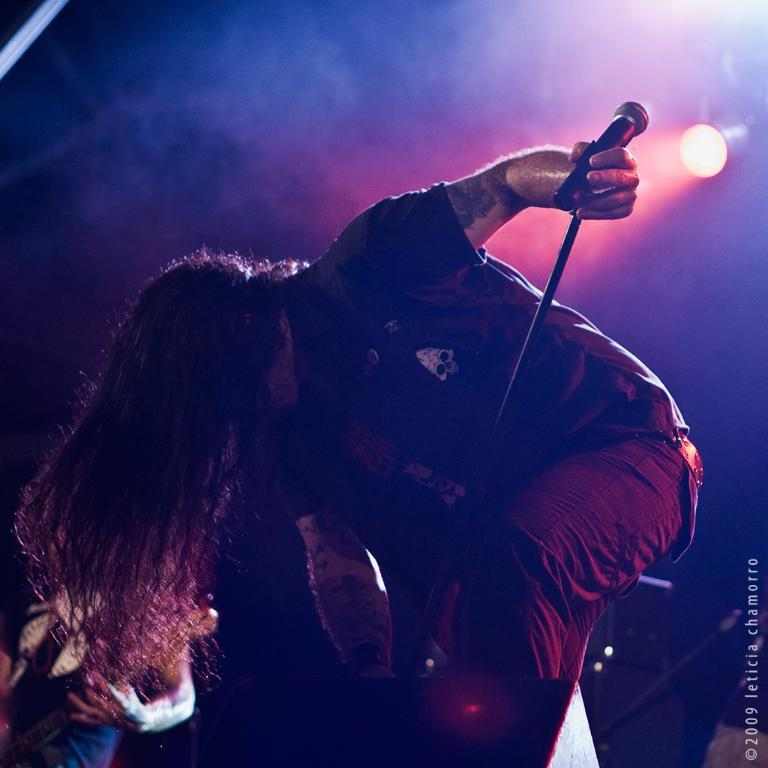What is the person holding in the image? The person is holding a mic with a stand. What can be seen in the image that might be used for lighting purposes? There is a focusing light in the image. What instrument is the man playing in the image? The man is playing a guitar in the image. Is there any text or logo visible in the image? Yes, there is a watermark in the bottom right side of the image. Reasoning: Let's think step by step by step in order to produce the conversation. We start by identifying the main subjects and objects in the image based on the provided facts. We then formulate questions that focus on the location and characteristics of these subjects and objects, ensuring that each question can be answered definitively with the information given. We avoid yes/no questions and ensure that the language is simple and clear. Absurd Question/Answer: What type of activity is the person's nose involved in within the image? There is no indication of the person's nose being involved in any activity in the image. What type of title can be seen on the guitar in the image? There is no title visible on the guitar in the image. What type of nose is the person playing the guitar in the image? There is no indication of the person's nose being involved in any activity in the image. 